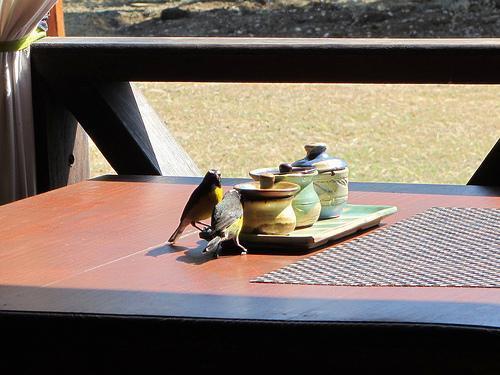How many birds on the table?
Give a very brief answer. 2. How many jars on the table?
Give a very brief answer. 3. 